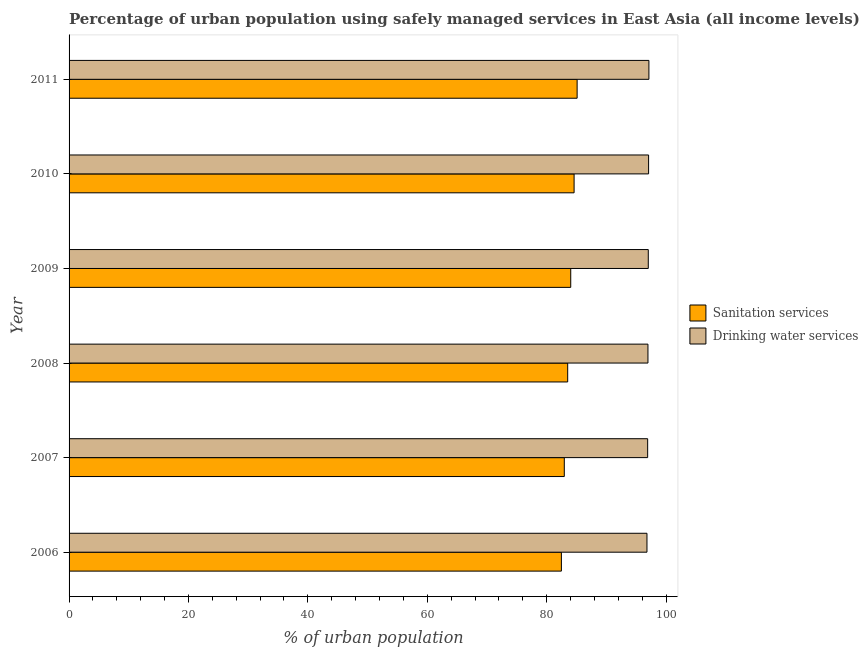How many different coloured bars are there?
Your answer should be very brief. 2. How many groups of bars are there?
Ensure brevity in your answer.  6. Are the number of bars per tick equal to the number of legend labels?
Offer a very short reply. Yes. How many bars are there on the 3rd tick from the top?
Offer a terse response. 2. How many bars are there on the 4th tick from the bottom?
Your answer should be very brief. 2. What is the percentage of urban population who used drinking water services in 2007?
Make the answer very short. 96.92. Across all years, what is the maximum percentage of urban population who used drinking water services?
Ensure brevity in your answer.  97.13. Across all years, what is the minimum percentage of urban population who used drinking water services?
Your answer should be very brief. 96.8. In which year was the percentage of urban population who used sanitation services maximum?
Offer a terse response. 2011. What is the total percentage of urban population who used sanitation services in the graph?
Your response must be concise. 502.67. What is the difference between the percentage of urban population who used drinking water services in 2009 and that in 2010?
Ensure brevity in your answer.  -0.05. What is the difference between the percentage of urban population who used drinking water services in 2011 and the percentage of urban population who used sanitation services in 2009?
Your response must be concise. 13.09. What is the average percentage of urban population who used drinking water services per year?
Your response must be concise. 96.98. In the year 2007, what is the difference between the percentage of urban population who used drinking water services and percentage of urban population who used sanitation services?
Your answer should be compact. 13.96. What is the ratio of the percentage of urban population who used sanitation services in 2009 to that in 2010?
Provide a short and direct response. 0.99. Is the percentage of urban population who used sanitation services in 2009 less than that in 2010?
Offer a terse response. Yes. Is the difference between the percentage of urban population who used sanitation services in 2007 and 2009 greater than the difference between the percentage of urban population who used drinking water services in 2007 and 2009?
Offer a very short reply. No. What is the difference between the highest and the second highest percentage of urban population who used drinking water services?
Keep it short and to the point. 0.05. What is the difference between the highest and the lowest percentage of urban population who used drinking water services?
Offer a terse response. 0.32. In how many years, is the percentage of urban population who used drinking water services greater than the average percentage of urban population who used drinking water services taken over all years?
Give a very brief answer. 3. Is the sum of the percentage of urban population who used sanitation services in 2009 and 2011 greater than the maximum percentage of urban population who used drinking water services across all years?
Keep it short and to the point. Yes. What does the 2nd bar from the top in 2006 represents?
Your response must be concise. Sanitation services. What does the 1st bar from the bottom in 2007 represents?
Your answer should be compact. Sanitation services. How many years are there in the graph?
Provide a short and direct response. 6. What is the difference between two consecutive major ticks on the X-axis?
Offer a very short reply. 20. Where does the legend appear in the graph?
Ensure brevity in your answer.  Center right. What is the title of the graph?
Your answer should be very brief. Percentage of urban population using safely managed services in East Asia (all income levels). Does "Lower secondary rate" appear as one of the legend labels in the graph?
Provide a succinct answer. No. What is the label or title of the X-axis?
Provide a succinct answer. % of urban population. What is the label or title of the Y-axis?
Provide a short and direct response. Year. What is the % of urban population of Sanitation services in 2006?
Offer a terse response. 82.47. What is the % of urban population in Drinking water services in 2006?
Offer a very short reply. 96.8. What is the % of urban population of Sanitation services in 2007?
Offer a terse response. 82.95. What is the % of urban population in Drinking water services in 2007?
Ensure brevity in your answer.  96.92. What is the % of urban population in Sanitation services in 2008?
Your response must be concise. 83.52. What is the % of urban population of Drinking water services in 2008?
Your response must be concise. 96.97. What is the % of urban population of Sanitation services in 2009?
Your answer should be very brief. 84.03. What is the % of urban population in Drinking water services in 2009?
Your response must be concise. 97.02. What is the % of urban population in Sanitation services in 2010?
Ensure brevity in your answer.  84.6. What is the % of urban population in Drinking water services in 2010?
Provide a short and direct response. 97.07. What is the % of urban population in Sanitation services in 2011?
Keep it short and to the point. 85.1. What is the % of urban population of Drinking water services in 2011?
Offer a very short reply. 97.13. Across all years, what is the maximum % of urban population of Sanitation services?
Offer a terse response. 85.1. Across all years, what is the maximum % of urban population of Drinking water services?
Your answer should be compact. 97.13. Across all years, what is the minimum % of urban population in Sanitation services?
Provide a short and direct response. 82.47. Across all years, what is the minimum % of urban population in Drinking water services?
Offer a terse response. 96.8. What is the total % of urban population in Sanitation services in the graph?
Offer a terse response. 502.67. What is the total % of urban population of Drinking water services in the graph?
Provide a short and direct response. 581.91. What is the difference between the % of urban population in Sanitation services in 2006 and that in 2007?
Your answer should be compact. -0.49. What is the difference between the % of urban population in Drinking water services in 2006 and that in 2007?
Give a very brief answer. -0.12. What is the difference between the % of urban population of Sanitation services in 2006 and that in 2008?
Keep it short and to the point. -1.05. What is the difference between the % of urban population of Drinking water services in 2006 and that in 2008?
Provide a short and direct response. -0.17. What is the difference between the % of urban population in Sanitation services in 2006 and that in 2009?
Offer a terse response. -1.56. What is the difference between the % of urban population in Drinking water services in 2006 and that in 2009?
Offer a very short reply. -0.22. What is the difference between the % of urban population in Sanitation services in 2006 and that in 2010?
Provide a short and direct response. -2.13. What is the difference between the % of urban population in Drinking water services in 2006 and that in 2010?
Keep it short and to the point. -0.27. What is the difference between the % of urban population in Sanitation services in 2006 and that in 2011?
Provide a succinct answer. -2.64. What is the difference between the % of urban population of Drinking water services in 2006 and that in 2011?
Give a very brief answer. -0.32. What is the difference between the % of urban population in Sanitation services in 2007 and that in 2008?
Make the answer very short. -0.57. What is the difference between the % of urban population of Drinking water services in 2007 and that in 2008?
Provide a short and direct response. -0.05. What is the difference between the % of urban population in Sanitation services in 2007 and that in 2009?
Your response must be concise. -1.08. What is the difference between the % of urban population in Drinking water services in 2007 and that in 2009?
Keep it short and to the point. -0.1. What is the difference between the % of urban population of Sanitation services in 2007 and that in 2010?
Make the answer very short. -1.64. What is the difference between the % of urban population of Drinking water services in 2007 and that in 2010?
Your answer should be compact. -0.16. What is the difference between the % of urban population in Sanitation services in 2007 and that in 2011?
Give a very brief answer. -2.15. What is the difference between the % of urban population of Drinking water services in 2007 and that in 2011?
Provide a succinct answer. -0.21. What is the difference between the % of urban population in Sanitation services in 2008 and that in 2009?
Give a very brief answer. -0.51. What is the difference between the % of urban population of Drinking water services in 2008 and that in 2009?
Offer a very short reply. -0.05. What is the difference between the % of urban population in Sanitation services in 2008 and that in 2010?
Your response must be concise. -1.08. What is the difference between the % of urban population in Drinking water services in 2008 and that in 2010?
Provide a succinct answer. -0.11. What is the difference between the % of urban population of Sanitation services in 2008 and that in 2011?
Ensure brevity in your answer.  -1.58. What is the difference between the % of urban population of Drinking water services in 2008 and that in 2011?
Your answer should be compact. -0.16. What is the difference between the % of urban population in Sanitation services in 2009 and that in 2010?
Your answer should be very brief. -0.56. What is the difference between the % of urban population in Drinking water services in 2009 and that in 2010?
Offer a very short reply. -0.05. What is the difference between the % of urban population in Sanitation services in 2009 and that in 2011?
Your response must be concise. -1.07. What is the difference between the % of urban population in Drinking water services in 2009 and that in 2011?
Offer a terse response. -0.11. What is the difference between the % of urban population of Sanitation services in 2010 and that in 2011?
Ensure brevity in your answer.  -0.51. What is the difference between the % of urban population in Drinking water services in 2010 and that in 2011?
Give a very brief answer. -0.05. What is the difference between the % of urban population of Sanitation services in 2006 and the % of urban population of Drinking water services in 2007?
Give a very brief answer. -14.45. What is the difference between the % of urban population in Sanitation services in 2006 and the % of urban population in Drinking water services in 2008?
Your answer should be compact. -14.5. What is the difference between the % of urban population in Sanitation services in 2006 and the % of urban population in Drinking water services in 2009?
Ensure brevity in your answer.  -14.55. What is the difference between the % of urban population in Sanitation services in 2006 and the % of urban population in Drinking water services in 2010?
Make the answer very short. -14.61. What is the difference between the % of urban population of Sanitation services in 2006 and the % of urban population of Drinking water services in 2011?
Your response must be concise. -14.66. What is the difference between the % of urban population in Sanitation services in 2007 and the % of urban population in Drinking water services in 2008?
Keep it short and to the point. -14.01. What is the difference between the % of urban population in Sanitation services in 2007 and the % of urban population in Drinking water services in 2009?
Your answer should be compact. -14.07. What is the difference between the % of urban population in Sanitation services in 2007 and the % of urban population in Drinking water services in 2010?
Offer a very short reply. -14.12. What is the difference between the % of urban population in Sanitation services in 2007 and the % of urban population in Drinking water services in 2011?
Offer a very short reply. -14.17. What is the difference between the % of urban population in Sanitation services in 2008 and the % of urban population in Drinking water services in 2009?
Offer a very short reply. -13.5. What is the difference between the % of urban population of Sanitation services in 2008 and the % of urban population of Drinking water services in 2010?
Keep it short and to the point. -13.55. What is the difference between the % of urban population of Sanitation services in 2008 and the % of urban population of Drinking water services in 2011?
Keep it short and to the point. -13.61. What is the difference between the % of urban population in Sanitation services in 2009 and the % of urban population in Drinking water services in 2010?
Your response must be concise. -13.04. What is the difference between the % of urban population in Sanitation services in 2009 and the % of urban population in Drinking water services in 2011?
Your response must be concise. -13.09. What is the difference between the % of urban population of Sanitation services in 2010 and the % of urban population of Drinking water services in 2011?
Your answer should be very brief. -12.53. What is the average % of urban population in Sanitation services per year?
Your answer should be compact. 83.78. What is the average % of urban population in Drinking water services per year?
Offer a very short reply. 96.98. In the year 2006, what is the difference between the % of urban population of Sanitation services and % of urban population of Drinking water services?
Offer a terse response. -14.33. In the year 2007, what is the difference between the % of urban population in Sanitation services and % of urban population in Drinking water services?
Keep it short and to the point. -13.96. In the year 2008, what is the difference between the % of urban population of Sanitation services and % of urban population of Drinking water services?
Give a very brief answer. -13.45. In the year 2009, what is the difference between the % of urban population of Sanitation services and % of urban population of Drinking water services?
Keep it short and to the point. -12.99. In the year 2010, what is the difference between the % of urban population of Sanitation services and % of urban population of Drinking water services?
Your answer should be compact. -12.48. In the year 2011, what is the difference between the % of urban population of Sanitation services and % of urban population of Drinking water services?
Provide a succinct answer. -12.02. What is the ratio of the % of urban population of Drinking water services in 2006 to that in 2007?
Your answer should be very brief. 1. What is the ratio of the % of urban population of Sanitation services in 2006 to that in 2008?
Offer a terse response. 0.99. What is the ratio of the % of urban population in Sanitation services in 2006 to that in 2009?
Keep it short and to the point. 0.98. What is the ratio of the % of urban population in Drinking water services in 2006 to that in 2009?
Your answer should be compact. 1. What is the ratio of the % of urban population in Sanitation services in 2006 to that in 2010?
Provide a succinct answer. 0.97. What is the ratio of the % of urban population of Drinking water services in 2006 to that in 2010?
Make the answer very short. 1. What is the ratio of the % of urban population of Sanitation services in 2006 to that in 2011?
Ensure brevity in your answer.  0.97. What is the ratio of the % of urban population of Drinking water services in 2006 to that in 2011?
Make the answer very short. 1. What is the ratio of the % of urban population of Sanitation services in 2007 to that in 2009?
Make the answer very short. 0.99. What is the ratio of the % of urban population of Sanitation services in 2007 to that in 2010?
Ensure brevity in your answer.  0.98. What is the ratio of the % of urban population of Drinking water services in 2007 to that in 2010?
Provide a short and direct response. 1. What is the ratio of the % of urban population of Sanitation services in 2007 to that in 2011?
Your response must be concise. 0.97. What is the ratio of the % of urban population of Sanitation services in 2008 to that in 2009?
Your response must be concise. 0.99. What is the ratio of the % of urban population of Drinking water services in 2008 to that in 2009?
Your answer should be very brief. 1. What is the ratio of the % of urban population in Sanitation services in 2008 to that in 2010?
Your response must be concise. 0.99. What is the ratio of the % of urban population of Drinking water services in 2008 to that in 2010?
Give a very brief answer. 1. What is the ratio of the % of urban population in Sanitation services in 2008 to that in 2011?
Provide a short and direct response. 0.98. What is the ratio of the % of urban population in Sanitation services in 2009 to that in 2011?
Offer a terse response. 0.99. What is the ratio of the % of urban population in Drinking water services in 2009 to that in 2011?
Your answer should be very brief. 1. What is the difference between the highest and the second highest % of urban population in Sanitation services?
Ensure brevity in your answer.  0.51. What is the difference between the highest and the second highest % of urban population in Drinking water services?
Give a very brief answer. 0.05. What is the difference between the highest and the lowest % of urban population of Sanitation services?
Keep it short and to the point. 2.64. What is the difference between the highest and the lowest % of urban population in Drinking water services?
Provide a short and direct response. 0.32. 